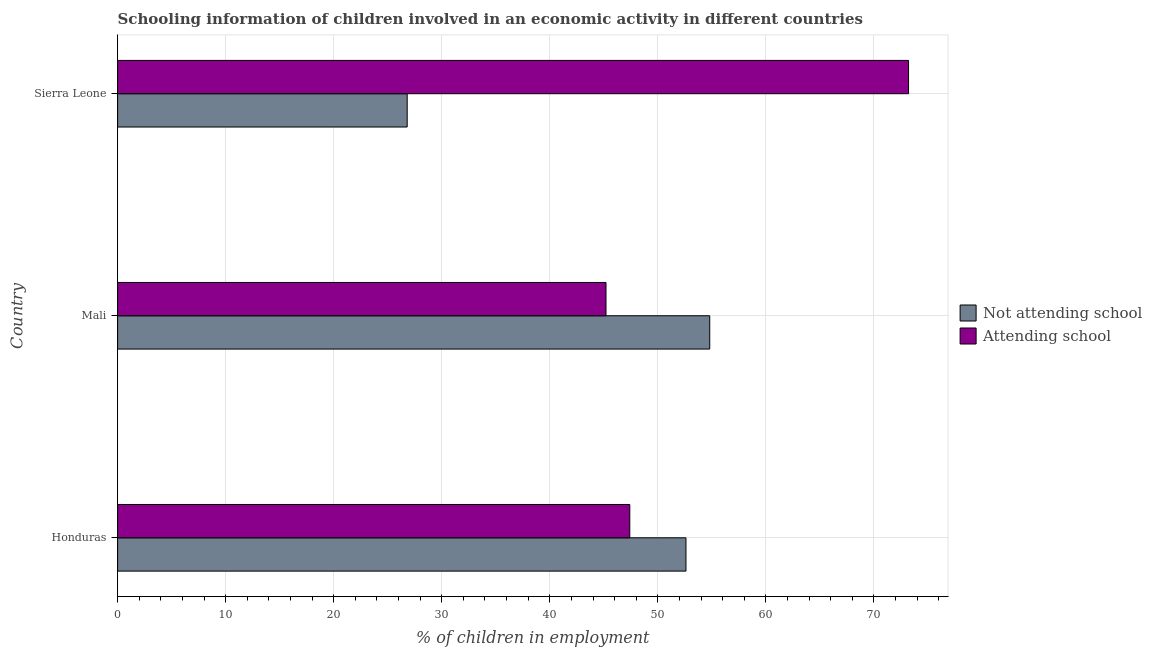How many bars are there on the 2nd tick from the top?
Ensure brevity in your answer.  2. What is the label of the 3rd group of bars from the top?
Ensure brevity in your answer.  Honduras. In how many cases, is the number of bars for a given country not equal to the number of legend labels?
Your answer should be very brief. 0. What is the percentage of employed children who are not attending school in Mali?
Provide a succinct answer. 54.8. Across all countries, what is the maximum percentage of employed children who are not attending school?
Your response must be concise. 54.8. Across all countries, what is the minimum percentage of employed children who are attending school?
Your response must be concise. 45.2. In which country was the percentage of employed children who are attending school maximum?
Make the answer very short. Sierra Leone. In which country was the percentage of employed children who are not attending school minimum?
Provide a succinct answer. Sierra Leone. What is the total percentage of employed children who are attending school in the graph?
Provide a succinct answer. 165.8. What is the difference between the percentage of employed children who are not attending school in Honduras and that in Sierra Leone?
Provide a short and direct response. 25.8. What is the difference between the percentage of employed children who are attending school in Honduras and the percentage of employed children who are not attending school in Sierra Leone?
Provide a succinct answer. 20.6. What is the average percentage of employed children who are attending school per country?
Keep it short and to the point. 55.27. In how many countries, is the percentage of employed children who are not attending school greater than 34 %?
Provide a short and direct response. 2. What is the ratio of the percentage of employed children who are not attending school in Mali to that in Sierra Leone?
Your response must be concise. 2.04. What does the 2nd bar from the top in Sierra Leone represents?
Offer a very short reply. Not attending school. What does the 1st bar from the bottom in Sierra Leone represents?
Offer a terse response. Not attending school. How many legend labels are there?
Make the answer very short. 2. How are the legend labels stacked?
Offer a terse response. Vertical. What is the title of the graph?
Your answer should be very brief. Schooling information of children involved in an economic activity in different countries. What is the label or title of the X-axis?
Provide a short and direct response. % of children in employment. What is the label or title of the Y-axis?
Your response must be concise. Country. What is the % of children in employment of Not attending school in Honduras?
Your response must be concise. 52.6. What is the % of children in employment in Attending school in Honduras?
Your response must be concise. 47.4. What is the % of children in employment in Not attending school in Mali?
Provide a short and direct response. 54.8. What is the % of children in employment in Attending school in Mali?
Make the answer very short. 45.2. What is the % of children in employment of Not attending school in Sierra Leone?
Make the answer very short. 26.8. What is the % of children in employment in Attending school in Sierra Leone?
Offer a very short reply. 73.2. Across all countries, what is the maximum % of children in employment in Not attending school?
Provide a succinct answer. 54.8. Across all countries, what is the maximum % of children in employment of Attending school?
Your answer should be very brief. 73.2. Across all countries, what is the minimum % of children in employment in Not attending school?
Offer a terse response. 26.8. Across all countries, what is the minimum % of children in employment of Attending school?
Make the answer very short. 45.2. What is the total % of children in employment in Not attending school in the graph?
Give a very brief answer. 134.2. What is the total % of children in employment in Attending school in the graph?
Make the answer very short. 165.8. What is the difference between the % of children in employment in Not attending school in Honduras and that in Mali?
Give a very brief answer. -2.2. What is the difference between the % of children in employment of Not attending school in Honduras and that in Sierra Leone?
Give a very brief answer. 25.8. What is the difference between the % of children in employment of Attending school in Honduras and that in Sierra Leone?
Keep it short and to the point. -25.8. What is the difference between the % of children in employment of Not attending school in Mali and that in Sierra Leone?
Your response must be concise. 28. What is the difference between the % of children in employment of Not attending school in Honduras and the % of children in employment of Attending school in Mali?
Your answer should be very brief. 7.4. What is the difference between the % of children in employment of Not attending school in Honduras and the % of children in employment of Attending school in Sierra Leone?
Offer a terse response. -20.6. What is the difference between the % of children in employment of Not attending school in Mali and the % of children in employment of Attending school in Sierra Leone?
Provide a succinct answer. -18.4. What is the average % of children in employment in Not attending school per country?
Offer a very short reply. 44.73. What is the average % of children in employment of Attending school per country?
Your answer should be very brief. 55.27. What is the difference between the % of children in employment of Not attending school and % of children in employment of Attending school in Honduras?
Your response must be concise. 5.2. What is the difference between the % of children in employment in Not attending school and % of children in employment in Attending school in Sierra Leone?
Your response must be concise. -46.4. What is the ratio of the % of children in employment in Not attending school in Honduras to that in Mali?
Offer a very short reply. 0.96. What is the ratio of the % of children in employment of Attending school in Honduras to that in Mali?
Offer a very short reply. 1.05. What is the ratio of the % of children in employment of Not attending school in Honduras to that in Sierra Leone?
Your answer should be very brief. 1.96. What is the ratio of the % of children in employment of Attending school in Honduras to that in Sierra Leone?
Give a very brief answer. 0.65. What is the ratio of the % of children in employment of Not attending school in Mali to that in Sierra Leone?
Your response must be concise. 2.04. What is the ratio of the % of children in employment in Attending school in Mali to that in Sierra Leone?
Provide a short and direct response. 0.62. What is the difference between the highest and the second highest % of children in employment in Not attending school?
Your response must be concise. 2.2. What is the difference between the highest and the second highest % of children in employment of Attending school?
Provide a succinct answer. 25.8. What is the difference between the highest and the lowest % of children in employment in Attending school?
Provide a short and direct response. 28. 